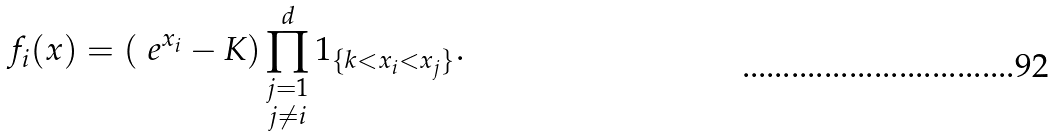<formula> <loc_0><loc_0><loc_500><loc_500>f _ { i } ( x ) = ( \ e ^ { x _ { i } } - K ) \prod _ { \substack { j = 1 \\ j \neq i } } ^ { d } 1 _ { \{ k < x _ { i } < x _ { j } \} } .</formula> 